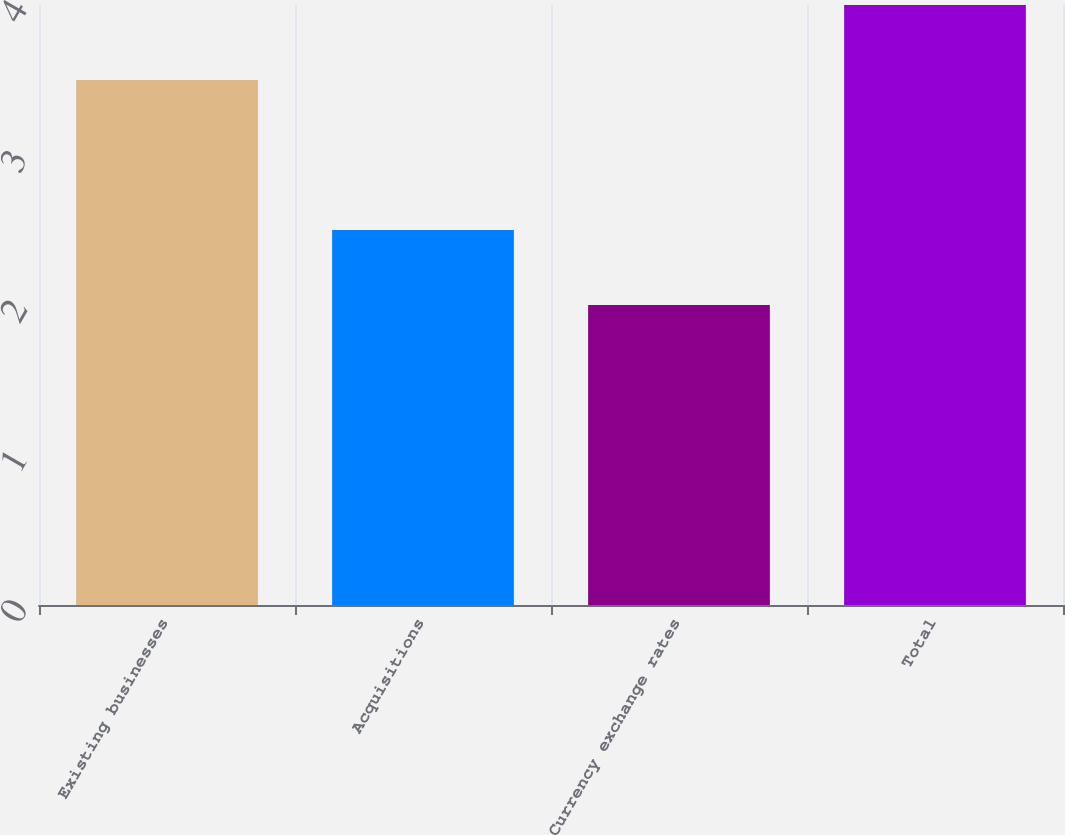Convert chart. <chart><loc_0><loc_0><loc_500><loc_500><bar_chart><fcel>Existing businesses<fcel>Acquisitions<fcel>Currency exchange rates<fcel>Total<nl><fcel>3.5<fcel>2.5<fcel>2<fcel>4<nl></chart> 